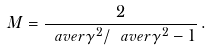<formula> <loc_0><loc_0><loc_500><loc_500>M = \frac { 2 } { \ a v e r { \gamma ^ { 2 } } / \ a v e r { \gamma } ^ { 2 } - 1 } \, .</formula> 